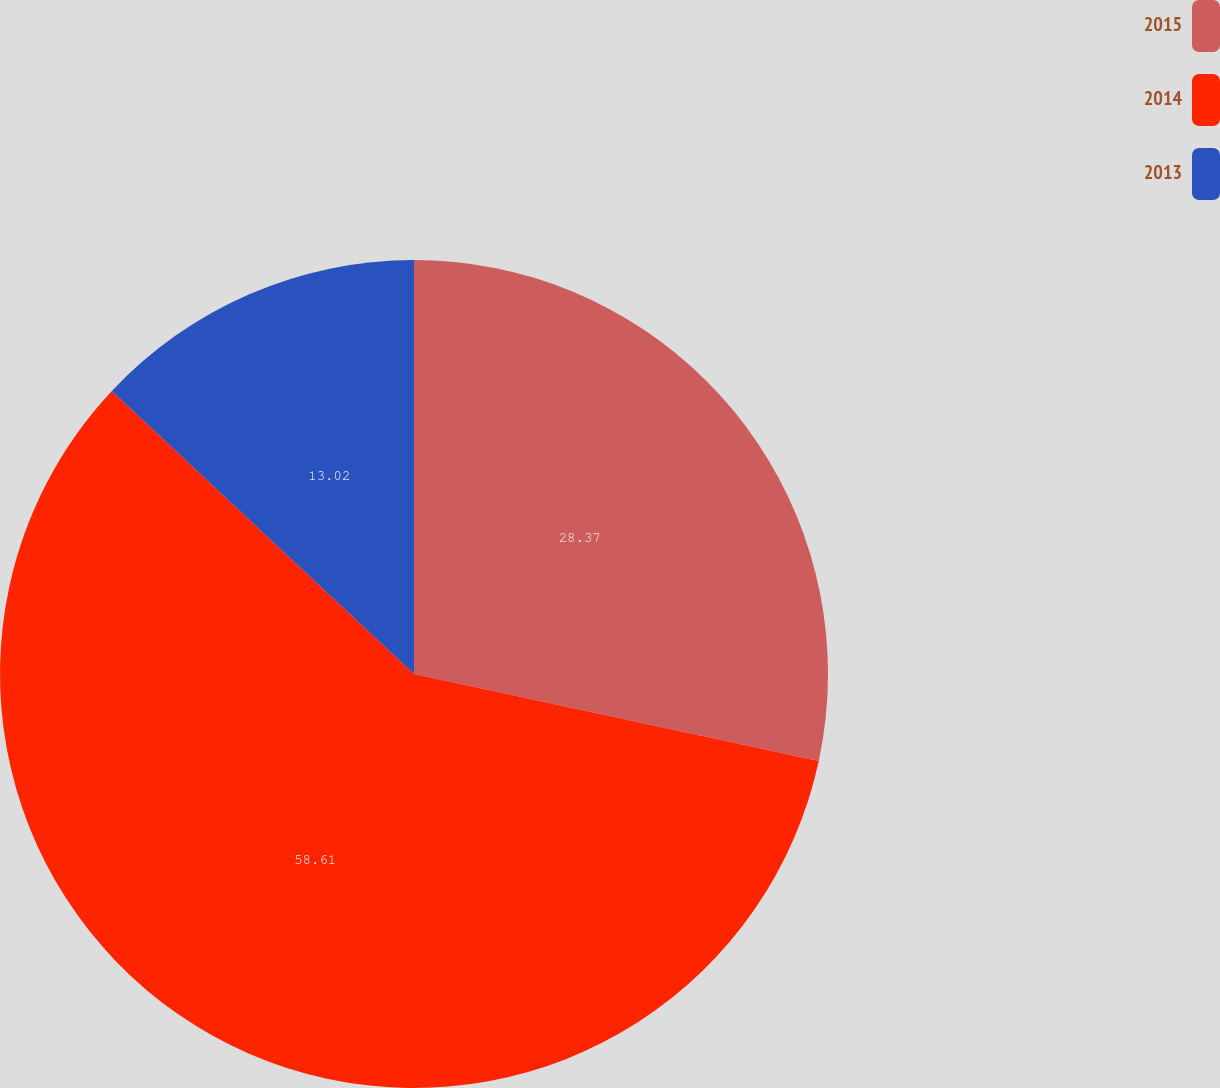Convert chart. <chart><loc_0><loc_0><loc_500><loc_500><pie_chart><fcel>2015<fcel>2014<fcel>2013<nl><fcel>28.37%<fcel>58.6%<fcel>13.02%<nl></chart> 